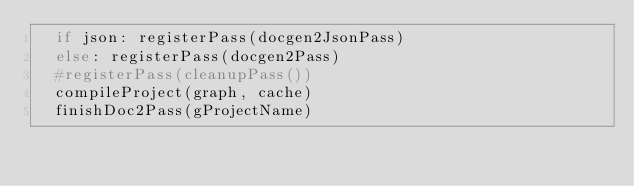<code> <loc_0><loc_0><loc_500><loc_500><_Nim_>  if json: registerPass(docgen2JsonPass)
  else: registerPass(docgen2Pass)
  #registerPass(cleanupPass())
  compileProject(graph, cache)
  finishDoc2Pass(gProjectName)
</code> 